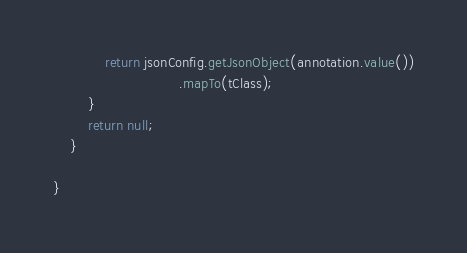<code> <loc_0><loc_0><loc_500><loc_500><_Java_>            return jsonConfig.getJsonObject(annotation.value())
                             .mapTo(tClass);
        }
        return null;
    }

}
</code> 